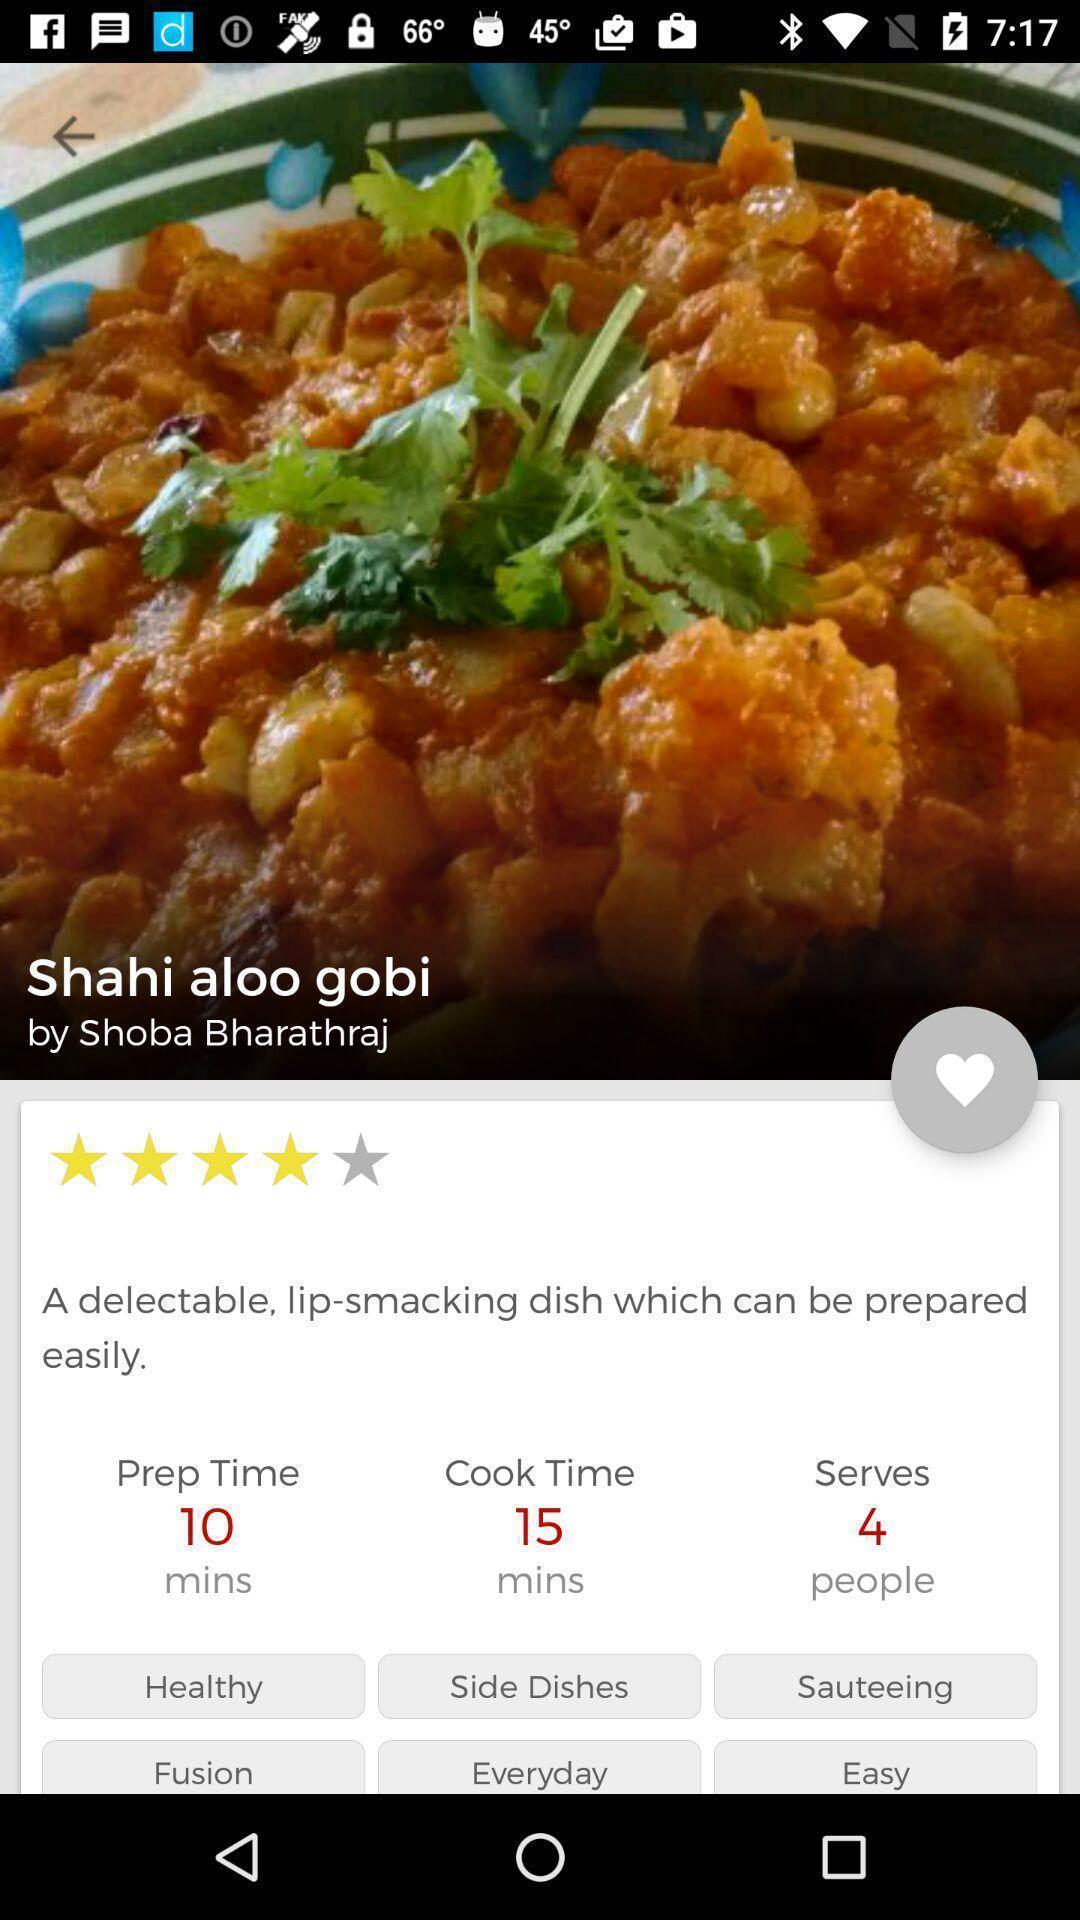What can you discern from this picture? Screen shows food item with ratings. 